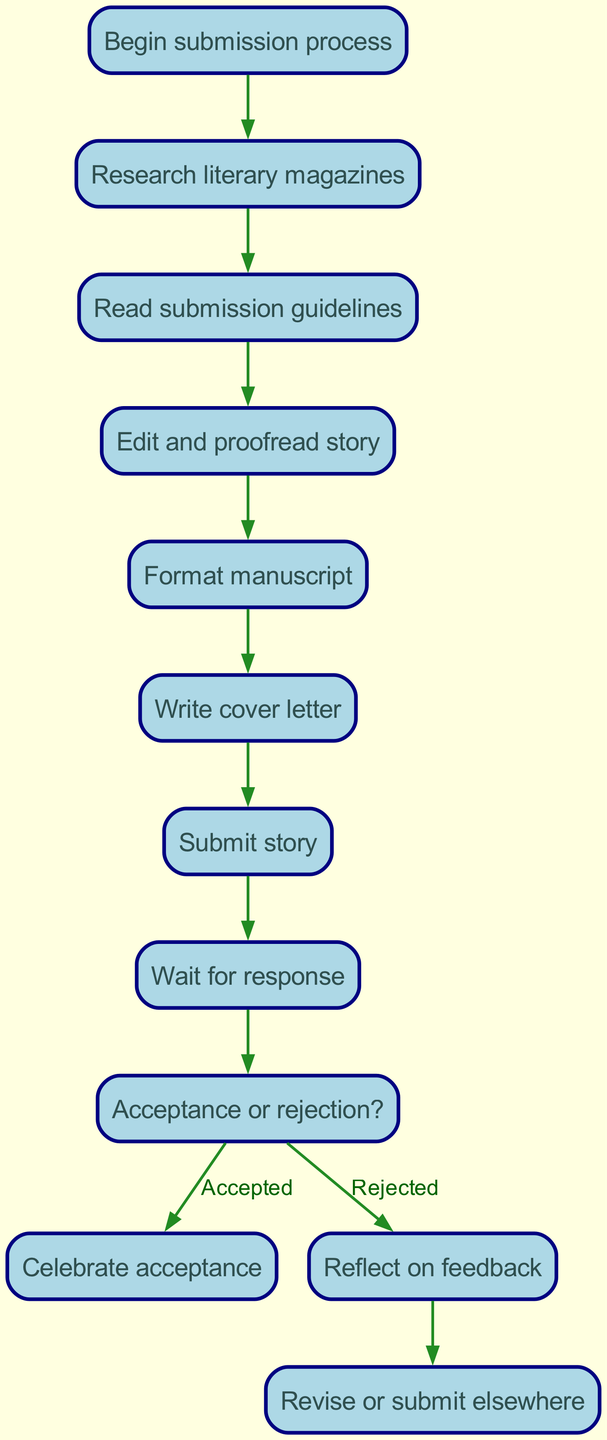What is the first step in the submission process? The diagram indicates that the first step is labeled "Begin submission process" and is the starting point from which all other nodes connect.
Answer: Begin submission process How many total steps are there in the process? Counting all the unique nodes in the diagram, there are a total of 11 steps or nodes that outline the submission process.
Answer: 11 What follows after "Write cover letter"? By following the diagram's flow, after "Write cover letter", the next step is "Submit story", which indicates the completion of the preparation phase.
Answer: Submit story What are the two possible outcomes after submitting the story? The diagram illustrates two paths from the "decision" node: one leads to "Celebrate acceptance" and the other leads to "Reflect on feedback", indicating the outcomes depending on whether the story was accepted or rejected.
Answer: Celebrate acceptance and Reflect on feedback Which step involves making changes to the story? According to the diagram, the step "Revise or submit elsewhere" is where changes to the story are made based on feedback or after rejection.
Answer: Revise or submit elsewhere If the story is rejected, what is the immediate next step? The diagram shows that if the decision is rejection, the immediate next step is "Reflect on feedback", which suggests the author should consider the feedback received.
Answer: Reflect on feedback 